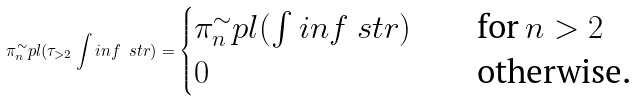<formula> <loc_0><loc_0><loc_500><loc_500>\pi _ { n } ^ { \sim } p l ( \tau _ { > 2 } \int i n f \ s t r ) = \begin{cases} \pi _ { n } ^ { \sim } p l ( \int i n f \ s t r ) \quad & \text {for} \, n > 2 \\ 0 & \text {otherwise.} \end{cases}</formula> 